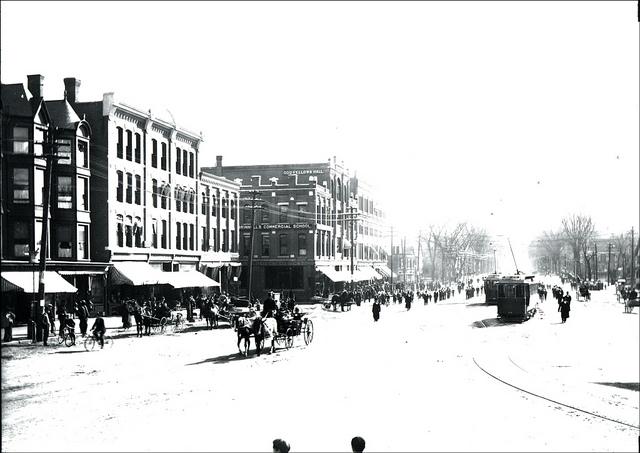Are there horses shown?
Give a very brief answer. Yes. Is this an old or new photo?
Concise answer only. Old. Is the photo in color?
Short answer required. No. 